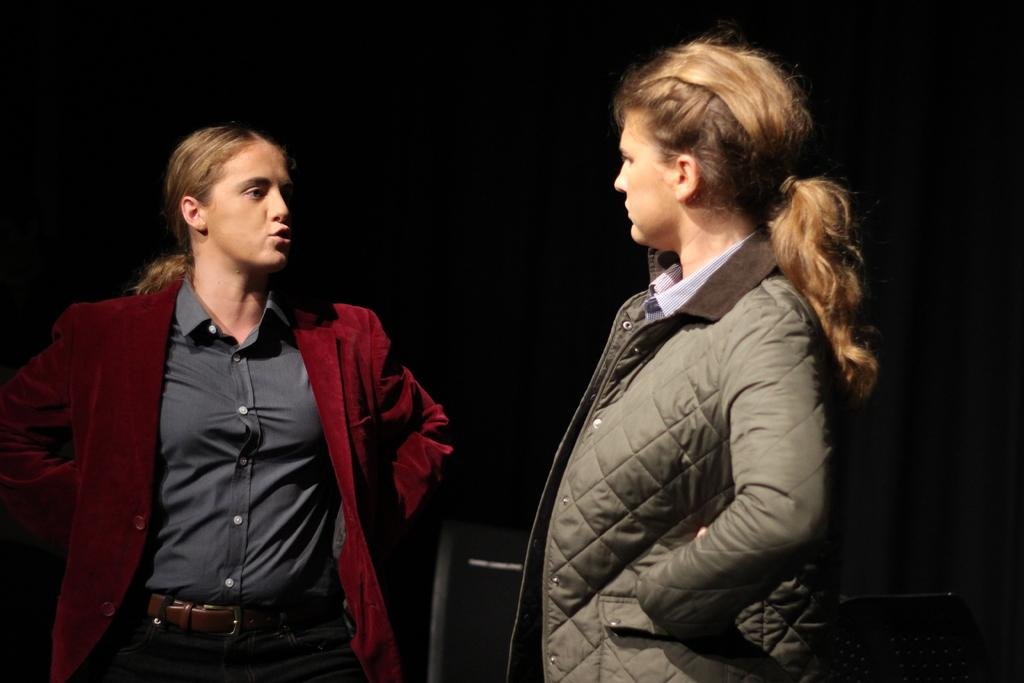How many people are in the foreground of the picture? There are two women in the foreground of the picture. What are the women doing in the image? The women are talking to each other. What is the color of the background in the image? The background of the image is dark. What can be seen in the middle of the image? There is a black color object in the middle of the image. What type of engine can be seen in the image? There is no engine present in the image. Is there a camp visible in the background of the image? There is no camp visible in the image; the background is dark. 